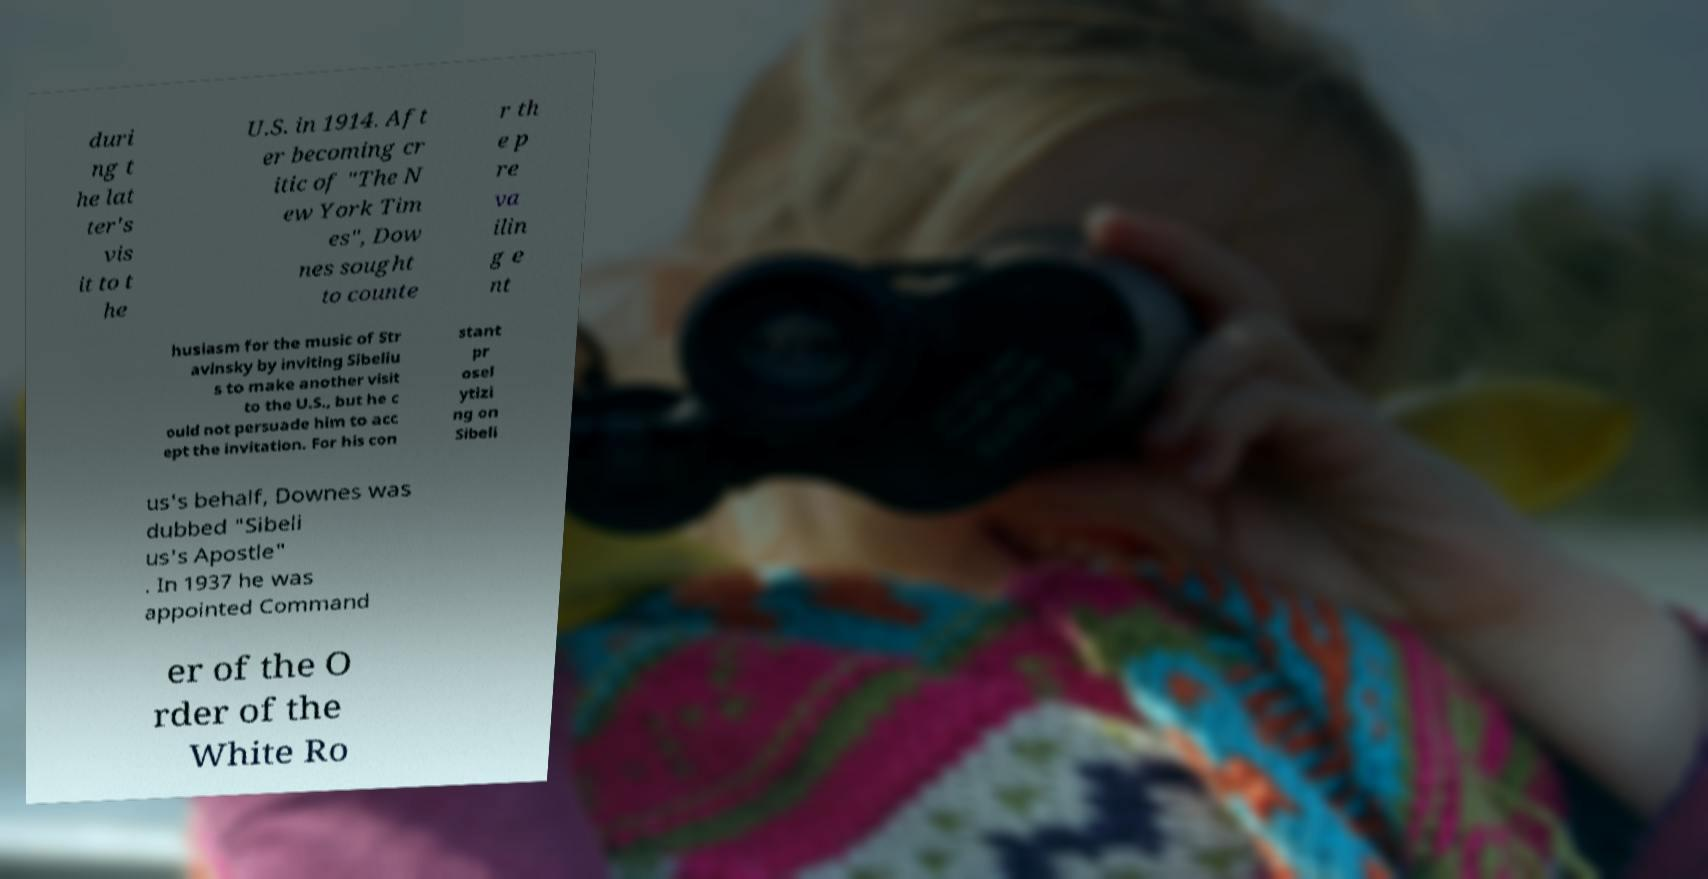What messages or text are displayed in this image? I need them in a readable, typed format. duri ng t he lat ter's vis it to t he U.S. in 1914. Aft er becoming cr itic of "The N ew York Tim es", Dow nes sought to counte r th e p re va ilin g e nt husiasm for the music of Str avinsky by inviting Sibeliu s to make another visit to the U.S., but he c ould not persuade him to acc ept the invitation. For his con stant pr osel ytizi ng on Sibeli us's behalf, Downes was dubbed "Sibeli us's Apostle" . In 1937 he was appointed Command er of the O rder of the White Ro 